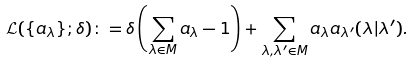<formula> <loc_0><loc_0><loc_500><loc_500>\mathcal { L } ( \{ a _ { \lambda } \} ; \delta ) \colon = \delta \left ( \sum _ { \lambda \in M } a _ { \lambda } - 1 \right ) + \sum _ { \lambda , \lambda ^ { \prime } \in M } a _ { \lambda } a _ { \lambda ^ { \prime } } ( \lambda | \lambda ^ { \prime } ) .</formula> 